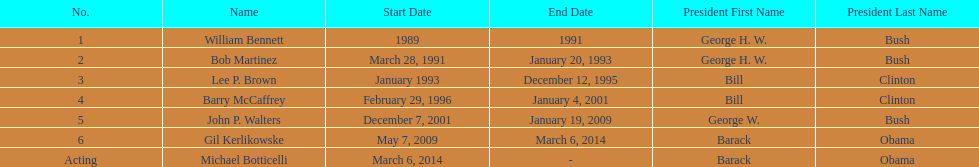What were the total number of years bob martinez served in office? 2. 